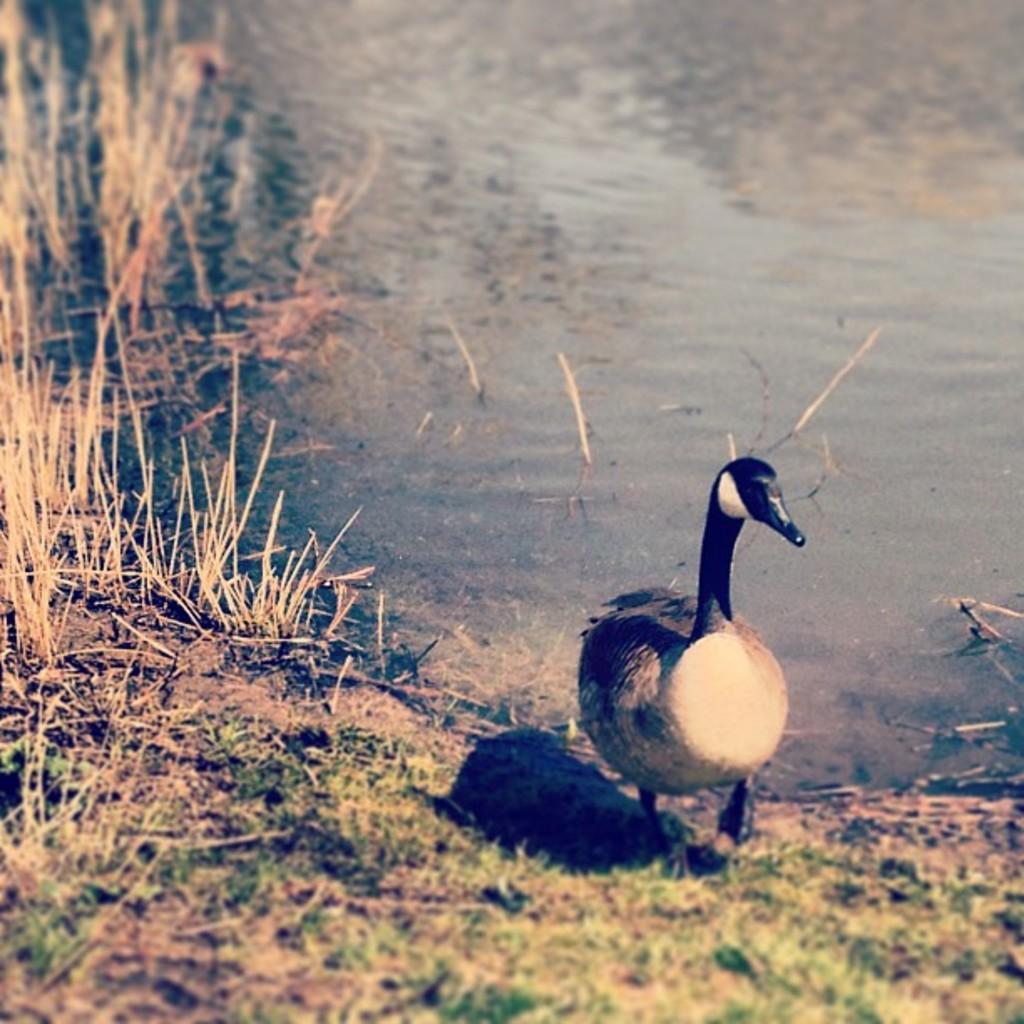Please provide a concise description of this image. Here there is a water body. On the foreground there is ground with grass and shrub. A bird is walking. 